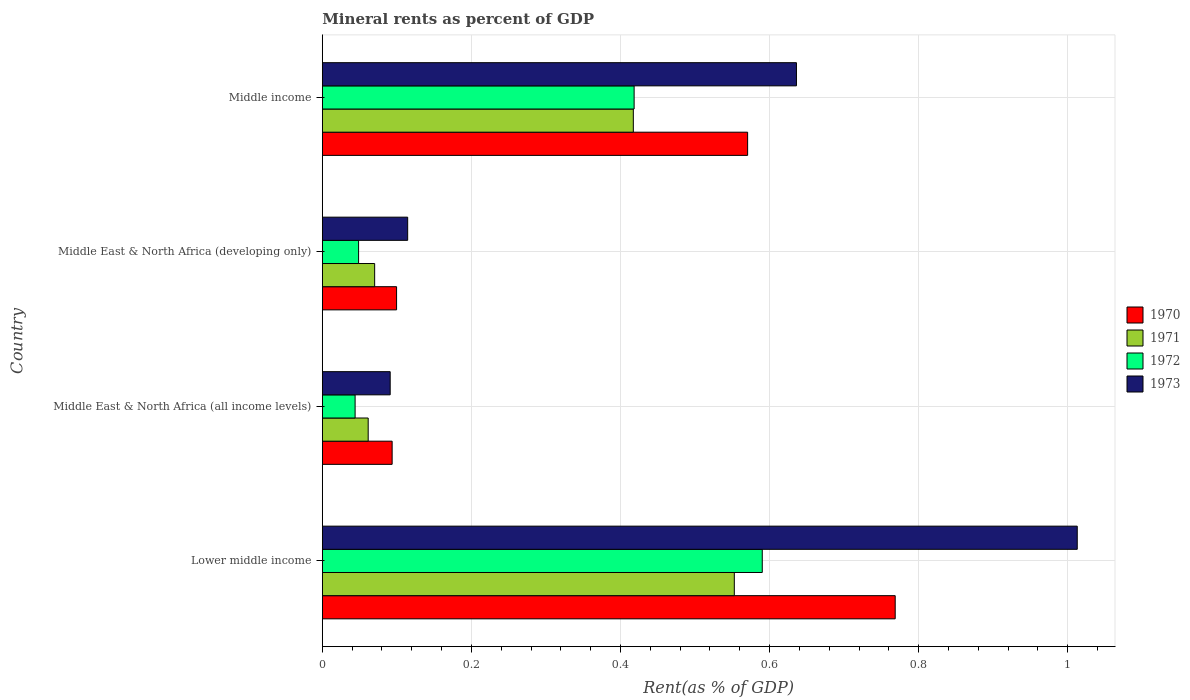How many different coloured bars are there?
Offer a very short reply. 4. How many groups of bars are there?
Provide a succinct answer. 4. Are the number of bars per tick equal to the number of legend labels?
Your response must be concise. Yes. What is the label of the 3rd group of bars from the top?
Offer a very short reply. Middle East & North Africa (all income levels). In how many cases, is the number of bars for a given country not equal to the number of legend labels?
Provide a short and direct response. 0. What is the mineral rent in 1973 in Lower middle income?
Your answer should be very brief. 1.01. Across all countries, what is the maximum mineral rent in 1970?
Your answer should be very brief. 0.77. Across all countries, what is the minimum mineral rent in 1973?
Your answer should be very brief. 0.09. In which country was the mineral rent in 1972 maximum?
Give a very brief answer. Lower middle income. In which country was the mineral rent in 1973 minimum?
Provide a succinct answer. Middle East & North Africa (all income levels). What is the total mineral rent in 1970 in the graph?
Your answer should be compact. 1.53. What is the difference between the mineral rent in 1972 in Middle East & North Africa (developing only) and that in Middle income?
Provide a short and direct response. -0.37. What is the difference between the mineral rent in 1973 in Middle income and the mineral rent in 1972 in Middle East & North Africa (developing only)?
Provide a short and direct response. 0.59. What is the average mineral rent in 1972 per country?
Give a very brief answer. 0.28. What is the difference between the mineral rent in 1973 and mineral rent in 1972 in Lower middle income?
Provide a succinct answer. 0.42. In how many countries, is the mineral rent in 1973 greater than 0.04 %?
Offer a very short reply. 4. What is the ratio of the mineral rent in 1972 in Middle East & North Africa (all income levels) to that in Middle income?
Make the answer very short. 0.11. What is the difference between the highest and the second highest mineral rent in 1970?
Offer a terse response. 0.2. What is the difference between the highest and the lowest mineral rent in 1972?
Offer a terse response. 0.55. Is the sum of the mineral rent in 1972 in Middle East & North Africa (all income levels) and Middle East & North Africa (developing only) greater than the maximum mineral rent in 1970 across all countries?
Make the answer very short. No. Is it the case that in every country, the sum of the mineral rent in 1970 and mineral rent in 1973 is greater than the mineral rent in 1971?
Your answer should be very brief. Yes. How many bars are there?
Your response must be concise. 16. How many countries are there in the graph?
Offer a terse response. 4. Are the values on the major ticks of X-axis written in scientific E-notation?
Your answer should be very brief. No. Does the graph contain any zero values?
Make the answer very short. No. Where does the legend appear in the graph?
Offer a very short reply. Center right. How many legend labels are there?
Keep it short and to the point. 4. What is the title of the graph?
Offer a terse response. Mineral rents as percent of GDP. Does "1971" appear as one of the legend labels in the graph?
Provide a succinct answer. Yes. What is the label or title of the X-axis?
Make the answer very short. Rent(as % of GDP). What is the Rent(as % of GDP) of 1970 in Lower middle income?
Your response must be concise. 0.77. What is the Rent(as % of GDP) of 1971 in Lower middle income?
Make the answer very short. 0.55. What is the Rent(as % of GDP) of 1972 in Lower middle income?
Provide a short and direct response. 0.59. What is the Rent(as % of GDP) of 1973 in Lower middle income?
Ensure brevity in your answer.  1.01. What is the Rent(as % of GDP) of 1970 in Middle East & North Africa (all income levels)?
Your answer should be compact. 0.09. What is the Rent(as % of GDP) in 1971 in Middle East & North Africa (all income levels)?
Ensure brevity in your answer.  0.06. What is the Rent(as % of GDP) of 1972 in Middle East & North Africa (all income levels)?
Your answer should be compact. 0.04. What is the Rent(as % of GDP) of 1973 in Middle East & North Africa (all income levels)?
Offer a terse response. 0.09. What is the Rent(as % of GDP) in 1970 in Middle East & North Africa (developing only)?
Provide a succinct answer. 0.1. What is the Rent(as % of GDP) of 1971 in Middle East & North Africa (developing only)?
Provide a succinct answer. 0.07. What is the Rent(as % of GDP) in 1972 in Middle East & North Africa (developing only)?
Your response must be concise. 0.05. What is the Rent(as % of GDP) in 1973 in Middle East & North Africa (developing only)?
Ensure brevity in your answer.  0.11. What is the Rent(as % of GDP) in 1970 in Middle income?
Your answer should be very brief. 0.57. What is the Rent(as % of GDP) in 1971 in Middle income?
Your answer should be very brief. 0.42. What is the Rent(as % of GDP) of 1972 in Middle income?
Your answer should be very brief. 0.42. What is the Rent(as % of GDP) in 1973 in Middle income?
Ensure brevity in your answer.  0.64. Across all countries, what is the maximum Rent(as % of GDP) of 1970?
Provide a succinct answer. 0.77. Across all countries, what is the maximum Rent(as % of GDP) in 1971?
Provide a succinct answer. 0.55. Across all countries, what is the maximum Rent(as % of GDP) of 1972?
Ensure brevity in your answer.  0.59. Across all countries, what is the maximum Rent(as % of GDP) in 1973?
Your answer should be very brief. 1.01. Across all countries, what is the minimum Rent(as % of GDP) in 1970?
Offer a terse response. 0.09. Across all countries, what is the minimum Rent(as % of GDP) in 1971?
Ensure brevity in your answer.  0.06. Across all countries, what is the minimum Rent(as % of GDP) in 1972?
Your answer should be compact. 0.04. Across all countries, what is the minimum Rent(as % of GDP) of 1973?
Your answer should be very brief. 0.09. What is the total Rent(as % of GDP) of 1970 in the graph?
Make the answer very short. 1.53. What is the total Rent(as % of GDP) in 1971 in the graph?
Offer a very short reply. 1.1. What is the total Rent(as % of GDP) in 1972 in the graph?
Make the answer very short. 1.1. What is the total Rent(as % of GDP) of 1973 in the graph?
Your answer should be compact. 1.85. What is the difference between the Rent(as % of GDP) of 1970 in Lower middle income and that in Middle East & North Africa (all income levels)?
Your answer should be compact. 0.67. What is the difference between the Rent(as % of GDP) in 1971 in Lower middle income and that in Middle East & North Africa (all income levels)?
Your answer should be compact. 0.49. What is the difference between the Rent(as % of GDP) of 1972 in Lower middle income and that in Middle East & North Africa (all income levels)?
Your answer should be compact. 0.55. What is the difference between the Rent(as % of GDP) in 1973 in Lower middle income and that in Middle East & North Africa (all income levels)?
Your response must be concise. 0.92. What is the difference between the Rent(as % of GDP) in 1970 in Lower middle income and that in Middle East & North Africa (developing only)?
Your response must be concise. 0.67. What is the difference between the Rent(as % of GDP) in 1971 in Lower middle income and that in Middle East & North Africa (developing only)?
Keep it short and to the point. 0.48. What is the difference between the Rent(as % of GDP) of 1972 in Lower middle income and that in Middle East & North Africa (developing only)?
Make the answer very short. 0.54. What is the difference between the Rent(as % of GDP) of 1973 in Lower middle income and that in Middle East & North Africa (developing only)?
Offer a terse response. 0.9. What is the difference between the Rent(as % of GDP) in 1970 in Lower middle income and that in Middle income?
Offer a very short reply. 0.2. What is the difference between the Rent(as % of GDP) of 1971 in Lower middle income and that in Middle income?
Provide a succinct answer. 0.14. What is the difference between the Rent(as % of GDP) in 1972 in Lower middle income and that in Middle income?
Provide a short and direct response. 0.17. What is the difference between the Rent(as % of GDP) of 1973 in Lower middle income and that in Middle income?
Offer a terse response. 0.38. What is the difference between the Rent(as % of GDP) of 1970 in Middle East & North Africa (all income levels) and that in Middle East & North Africa (developing only)?
Provide a succinct answer. -0.01. What is the difference between the Rent(as % of GDP) in 1971 in Middle East & North Africa (all income levels) and that in Middle East & North Africa (developing only)?
Your answer should be compact. -0.01. What is the difference between the Rent(as % of GDP) in 1972 in Middle East & North Africa (all income levels) and that in Middle East & North Africa (developing only)?
Keep it short and to the point. -0. What is the difference between the Rent(as % of GDP) of 1973 in Middle East & North Africa (all income levels) and that in Middle East & North Africa (developing only)?
Provide a short and direct response. -0.02. What is the difference between the Rent(as % of GDP) of 1970 in Middle East & North Africa (all income levels) and that in Middle income?
Your answer should be very brief. -0.48. What is the difference between the Rent(as % of GDP) of 1971 in Middle East & North Africa (all income levels) and that in Middle income?
Offer a very short reply. -0.36. What is the difference between the Rent(as % of GDP) in 1972 in Middle East & North Africa (all income levels) and that in Middle income?
Your answer should be compact. -0.37. What is the difference between the Rent(as % of GDP) of 1973 in Middle East & North Africa (all income levels) and that in Middle income?
Offer a very short reply. -0.55. What is the difference between the Rent(as % of GDP) in 1970 in Middle East & North Africa (developing only) and that in Middle income?
Make the answer very short. -0.47. What is the difference between the Rent(as % of GDP) of 1971 in Middle East & North Africa (developing only) and that in Middle income?
Make the answer very short. -0.35. What is the difference between the Rent(as % of GDP) in 1972 in Middle East & North Africa (developing only) and that in Middle income?
Give a very brief answer. -0.37. What is the difference between the Rent(as % of GDP) in 1973 in Middle East & North Africa (developing only) and that in Middle income?
Your answer should be very brief. -0.52. What is the difference between the Rent(as % of GDP) of 1970 in Lower middle income and the Rent(as % of GDP) of 1971 in Middle East & North Africa (all income levels)?
Make the answer very short. 0.71. What is the difference between the Rent(as % of GDP) of 1970 in Lower middle income and the Rent(as % of GDP) of 1972 in Middle East & North Africa (all income levels)?
Make the answer very short. 0.72. What is the difference between the Rent(as % of GDP) of 1970 in Lower middle income and the Rent(as % of GDP) of 1973 in Middle East & North Africa (all income levels)?
Your answer should be very brief. 0.68. What is the difference between the Rent(as % of GDP) of 1971 in Lower middle income and the Rent(as % of GDP) of 1972 in Middle East & North Africa (all income levels)?
Provide a succinct answer. 0.51. What is the difference between the Rent(as % of GDP) in 1971 in Lower middle income and the Rent(as % of GDP) in 1973 in Middle East & North Africa (all income levels)?
Keep it short and to the point. 0.46. What is the difference between the Rent(as % of GDP) in 1972 in Lower middle income and the Rent(as % of GDP) in 1973 in Middle East & North Africa (all income levels)?
Keep it short and to the point. 0.5. What is the difference between the Rent(as % of GDP) of 1970 in Lower middle income and the Rent(as % of GDP) of 1971 in Middle East & North Africa (developing only)?
Make the answer very short. 0.7. What is the difference between the Rent(as % of GDP) in 1970 in Lower middle income and the Rent(as % of GDP) in 1972 in Middle East & North Africa (developing only)?
Your answer should be compact. 0.72. What is the difference between the Rent(as % of GDP) in 1970 in Lower middle income and the Rent(as % of GDP) in 1973 in Middle East & North Africa (developing only)?
Give a very brief answer. 0.65. What is the difference between the Rent(as % of GDP) in 1971 in Lower middle income and the Rent(as % of GDP) in 1972 in Middle East & North Africa (developing only)?
Ensure brevity in your answer.  0.5. What is the difference between the Rent(as % of GDP) of 1971 in Lower middle income and the Rent(as % of GDP) of 1973 in Middle East & North Africa (developing only)?
Give a very brief answer. 0.44. What is the difference between the Rent(as % of GDP) in 1972 in Lower middle income and the Rent(as % of GDP) in 1973 in Middle East & North Africa (developing only)?
Your answer should be compact. 0.48. What is the difference between the Rent(as % of GDP) of 1970 in Lower middle income and the Rent(as % of GDP) of 1971 in Middle income?
Offer a very short reply. 0.35. What is the difference between the Rent(as % of GDP) of 1970 in Lower middle income and the Rent(as % of GDP) of 1972 in Middle income?
Give a very brief answer. 0.35. What is the difference between the Rent(as % of GDP) in 1970 in Lower middle income and the Rent(as % of GDP) in 1973 in Middle income?
Offer a terse response. 0.13. What is the difference between the Rent(as % of GDP) of 1971 in Lower middle income and the Rent(as % of GDP) of 1972 in Middle income?
Your answer should be compact. 0.13. What is the difference between the Rent(as % of GDP) of 1971 in Lower middle income and the Rent(as % of GDP) of 1973 in Middle income?
Your response must be concise. -0.08. What is the difference between the Rent(as % of GDP) of 1972 in Lower middle income and the Rent(as % of GDP) of 1973 in Middle income?
Provide a short and direct response. -0.05. What is the difference between the Rent(as % of GDP) of 1970 in Middle East & North Africa (all income levels) and the Rent(as % of GDP) of 1971 in Middle East & North Africa (developing only)?
Make the answer very short. 0.02. What is the difference between the Rent(as % of GDP) in 1970 in Middle East & North Africa (all income levels) and the Rent(as % of GDP) in 1972 in Middle East & North Africa (developing only)?
Your answer should be very brief. 0.04. What is the difference between the Rent(as % of GDP) of 1970 in Middle East & North Africa (all income levels) and the Rent(as % of GDP) of 1973 in Middle East & North Africa (developing only)?
Your answer should be compact. -0.02. What is the difference between the Rent(as % of GDP) in 1971 in Middle East & North Africa (all income levels) and the Rent(as % of GDP) in 1972 in Middle East & North Africa (developing only)?
Your response must be concise. 0.01. What is the difference between the Rent(as % of GDP) in 1971 in Middle East & North Africa (all income levels) and the Rent(as % of GDP) in 1973 in Middle East & North Africa (developing only)?
Make the answer very short. -0.05. What is the difference between the Rent(as % of GDP) of 1972 in Middle East & North Africa (all income levels) and the Rent(as % of GDP) of 1973 in Middle East & North Africa (developing only)?
Keep it short and to the point. -0.07. What is the difference between the Rent(as % of GDP) in 1970 in Middle East & North Africa (all income levels) and the Rent(as % of GDP) in 1971 in Middle income?
Your answer should be compact. -0.32. What is the difference between the Rent(as % of GDP) in 1970 in Middle East & North Africa (all income levels) and the Rent(as % of GDP) in 1972 in Middle income?
Provide a short and direct response. -0.32. What is the difference between the Rent(as % of GDP) in 1970 in Middle East & North Africa (all income levels) and the Rent(as % of GDP) in 1973 in Middle income?
Make the answer very short. -0.54. What is the difference between the Rent(as % of GDP) in 1971 in Middle East & North Africa (all income levels) and the Rent(as % of GDP) in 1972 in Middle income?
Your answer should be compact. -0.36. What is the difference between the Rent(as % of GDP) in 1971 in Middle East & North Africa (all income levels) and the Rent(as % of GDP) in 1973 in Middle income?
Keep it short and to the point. -0.57. What is the difference between the Rent(as % of GDP) of 1972 in Middle East & North Africa (all income levels) and the Rent(as % of GDP) of 1973 in Middle income?
Make the answer very short. -0.59. What is the difference between the Rent(as % of GDP) in 1970 in Middle East & North Africa (developing only) and the Rent(as % of GDP) in 1971 in Middle income?
Give a very brief answer. -0.32. What is the difference between the Rent(as % of GDP) in 1970 in Middle East & North Africa (developing only) and the Rent(as % of GDP) in 1972 in Middle income?
Keep it short and to the point. -0.32. What is the difference between the Rent(as % of GDP) in 1970 in Middle East & North Africa (developing only) and the Rent(as % of GDP) in 1973 in Middle income?
Make the answer very short. -0.54. What is the difference between the Rent(as % of GDP) in 1971 in Middle East & North Africa (developing only) and the Rent(as % of GDP) in 1972 in Middle income?
Offer a terse response. -0.35. What is the difference between the Rent(as % of GDP) of 1971 in Middle East & North Africa (developing only) and the Rent(as % of GDP) of 1973 in Middle income?
Your response must be concise. -0.57. What is the difference between the Rent(as % of GDP) of 1972 in Middle East & North Africa (developing only) and the Rent(as % of GDP) of 1973 in Middle income?
Offer a very short reply. -0.59. What is the average Rent(as % of GDP) of 1970 per country?
Provide a succinct answer. 0.38. What is the average Rent(as % of GDP) in 1971 per country?
Keep it short and to the point. 0.28. What is the average Rent(as % of GDP) in 1972 per country?
Provide a succinct answer. 0.28. What is the average Rent(as % of GDP) in 1973 per country?
Provide a short and direct response. 0.46. What is the difference between the Rent(as % of GDP) in 1970 and Rent(as % of GDP) in 1971 in Lower middle income?
Ensure brevity in your answer.  0.22. What is the difference between the Rent(as % of GDP) in 1970 and Rent(as % of GDP) in 1972 in Lower middle income?
Provide a succinct answer. 0.18. What is the difference between the Rent(as % of GDP) in 1970 and Rent(as % of GDP) in 1973 in Lower middle income?
Give a very brief answer. -0.24. What is the difference between the Rent(as % of GDP) of 1971 and Rent(as % of GDP) of 1972 in Lower middle income?
Offer a terse response. -0.04. What is the difference between the Rent(as % of GDP) of 1971 and Rent(as % of GDP) of 1973 in Lower middle income?
Keep it short and to the point. -0.46. What is the difference between the Rent(as % of GDP) in 1972 and Rent(as % of GDP) in 1973 in Lower middle income?
Give a very brief answer. -0.42. What is the difference between the Rent(as % of GDP) of 1970 and Rent(as % of GDP) of 1971 in Middle East & North Africa (all income levels)?
Your answer should be very brief. 0.03. What is the difference between the Rent(as % of GDP) in 1970 and Rent(as % of GDP) in 1972 in Middle East & North Africa (all income levels)?
Make the answer very short. 0.05. What is the difference between the Rent(as % of GDP) of 1970 and Rent(as % of GDP) of 1973 in Middle East & North Africa (all income levels)?
Keep it short and to the point. 0. What is the difference between the Rent(as % of GDP) in 1971 and Rent(as % of GDP) in 1972 in Middle East & North Africa (all income levels)?
Your answer should be compact. 0.02. What is the difference between the Rent(as % of GDP) of 1971 and Rent(as % of GDP) of 1973 in Middle East & North Africa (all income levels)?
Give a very brief answer. -0.03. What is the difference between the Rent(as % of GDP) of 1972 and Rent(as % of GDP) of 1973 in Middle East & North Africa (all income levels)?
Your answer should be very brief. -0.05. What is the difference between the Rent(as % of GDP) in 1970 and Rent(as % of GDP) in 1971 in Middle East & North Africa (developing only)?
Provide a short and direct response. 0.03. What is the difference between the Rent(as % of GDP) in 1970 and Rent(as % of GDP) in 1972 in Middle East & North Africa (developing only)?
Your response must be concise. 0.05. What is the difference between the Rent(as % of GDP) of 1970 and Rent(as % of GDP) of 1973 in Middle East & North Africa (developing only)?
Ensure brevity in your answer.  -0.01. What is the difference between the Rent(as % of GDP) of 1971 and Rent(as % of GDP) of 1972 in Middle East & North Africa (developing only)?
Your answer should be compact. 0.02. What is the difference between the Rent(as % of GDP) of 1971 and Rent(as % of GDP) of 1973 in Middle East & North Africa (developing only)?
Your answer should be very brief. -0.04. What is the difference between the Rent(as % of GDP) of 1972 and Rent(as % of GDP) of 1973 in Middle East & North Africa (developing only)?
Provide a succinct answer. -0.07. What is the difference between the Rent(as % of GDP) in 1970 and Rent(as % of GDP) in 1971 in Middle income?
Provide a succinct answer. 0.15. What is the difference between the Rent(as % of GDP) in 1970 and Rent(as % of GDP) in 1972 in Middle income?
Offer a terse response. 0.15. What is the difference between the Rent(as % of GDP) in 1970 and Rent(as % of GDP) in 1973 in Middle income?
Your answer should be compact. -0.07. What is the difference between the Rent(as % of GDP) of 1971 and Rent(as % of GDP) of 1972 in Middle income?
Give a very brief answer. -0. What is the difference between the Rent(as % of GDP) of 1971 and Rent(as % of GDP) of 1973 in Middle income?
Your answer should be very brief. -0.22. What is the difference between the Rent(as % of GDP) in 1972 and Rent(as % of GDP) in 1973 in Middle income?
Offer a very short reply. -0.22. What is the ratio of the Rent(as % of GDP) of 1970 in Lower middle income to that in Middle East & North Africa (all income levels)?
Give a very brief answer. 8.21. What is the ratio of the Rent(as % of GDP) of 1971 in Lower middle income to that in Middle East & North Africa (all income levels)?
Your answer should be very brief. 8.98. What is the ratio of the Rent(as % of GDP) of 1972 in Lower middle income to that in Middle East & North Africa (all income levels)?
Offer a very short reply. 13.42. What is the ratio of the Rent(as % of GDP) of 1973 in Lower middle income to that in Middle East & North Africa (all income levels)?
Provide a short and direct response. 11.12. What is the ratio of the Rent(as % of GDP) of 1970 in Lower middle income to that in Middle East & North Africa (developing only)?
Your answer should be compact. 7.72. What is the ratio of the Rent(as % of GDP) of 1971 in Lower middle income to that in Middle East & North Africa (developing only)?
Provide a succinct answer. 7.87. What is the ratio of the Rent(as % of GDP) in 1972 in Lower middle income to that in Middle East & North Africa (developing only)?
Ensure brevity in your answer.  12.13. What is the ratio of the Rent(as % of GDP) of 1973 in Lower middle income to that in Middle East & North Africa (developing only)?
Offer a terse response. 8.85. What is the ratio of the Rent(as % of GDP) in 1970 in Lower middle income to that in Middle income?
Your answer should be very brief. 1.35. What is the ratio of the Rent(as % of GDP) of 1971 in Lower middle income to that in Middle income?
Provide a succinct answer. 1.32. What is the ratio of the Rent(as % of GDP) in 1972 in Lower middle income to that in Middle income?
Offer a terse response. 1.41. What is the ratio of the Rent(as % of GDP) of 1973 in Lower middle income to that in Middle income?
Make the answer very short. 1.59. What is the ratio of the Rent(as % of GDP) of 1970 in Middle East & North Africa (all income levels) to that in Middle East & North Africa (developing only)?
Offer a terse response. 0.94. What is the ratio of the Rent(as % of GDP) in 1971 in Middle East & North Africa (all income levels) to that in Middle East & North Africa (developing only)?
Offer a terse response. 0.88. What is the ratio of the Rent(as % of GDP) of 1972 in Middle East & North Africa (all income levels) to that in Middle East & North Africa (developing only)?
Make the answer very short. 0.9. What is the ratio of the Rent(as % of GDP) in 1973 in Middle East & North Africa (all income levels) to that in Middle East & North Africa (developing only)?
Your answer should be very brief. 0.8. What is the ratio of the Rent(as % of GDP) of 1970 in Middle East & North Africa (all income levels) to that in Middle income?
Offer a terse response. 0.16. What is the ratio of the Rent(as % of GDP) in 1971 in Middle East & North Africa (all income levels) to that in Middle income?
Offer a terse response. 0.15. What is the ratio of the Rent(as % of GDP) of 1972 in Middle East & North Africa (all income levels) to that in Middle income?
Ensure brevity in your answer.  0.11. What is the ratio of the Rent(as % of GDP) in 1973 in Middle East & North Africa (all income levels) to that in Middle income?
Provide a short and direct response. 0.14. What is the ratio of the Rent(as % of GDP) in 1970 in Middle East & North Africa (developing only) to that in Middle income?
Ensure brevity in your answer.  0.17. What is the ratio of the Rent(as % of GDP) in 1971 in Middle East & North Africa (developing only) to that in Middle income?
Your answer should be compact. 0.17. What is the ratio of the Rent(as % of GDP) in 1972 in Middle East & North Africa (developing only) to that in Middle income?
Give a very brief answer. 0.12. What is the ratio of the Rent(as % of GDP) of 1973 in Middle East & North Africa (developing only) to that in Middle income?
Offer a very short reply. 0.18. What is the difference between the highest and the second highest Rent(as % of GDP) of 1970?
Give a very brief answer. 0.2. What is the difference between the highest and the second highest Rent(as % of GDP) of 1971?
Offer a terse response. 0.14. What is the difference between the highest and the second highest Rent(as % of GDP) in 1972?
Make the answer very short. 0.17. What is the difference between the highest and the second highest Rent(as % of GDP) of 1973?
Your answer should be very brief. 0.38. What is the difference between the highest and the lowest Rent(as % of GDP) of 1970?
Provide a short and direct response. 0.67. What is the difference between the highest and the lowest Rent(as % of GDP) in 1971?
Your answer should be compact. 0.49. What is the difference between the highest and the lowest Rent(as % of GDP) in 1972?
Keep it short and to the point. 0.55. What is the difference between the highest and the lowest Rent(as % of GDP) in 1973?
Your answer should be compact. 0.92. 